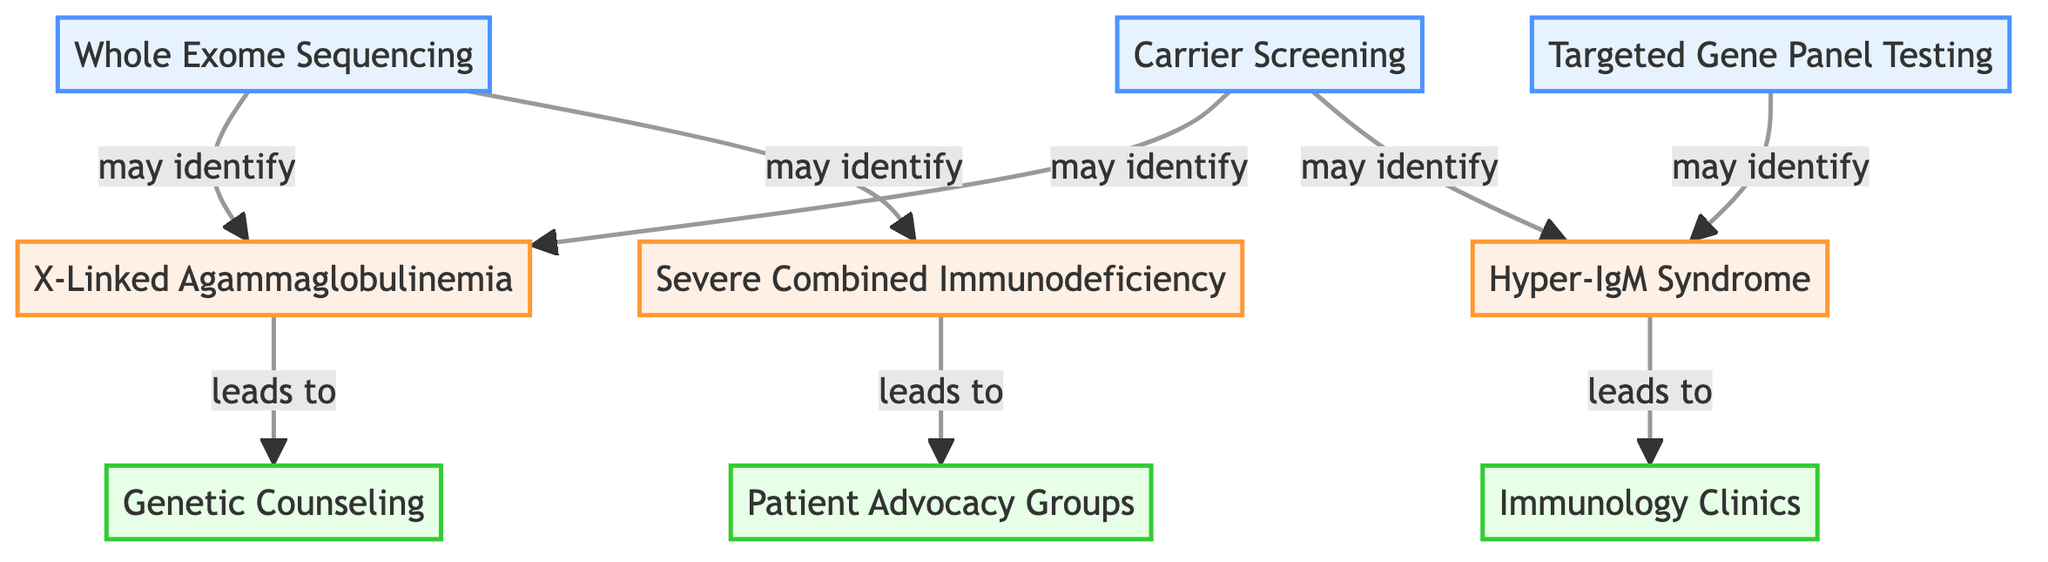What are the three genetic testing options displayed in the diagram? The nodes listed under "genetic_testing" include Whole Exome Sequencing, Targeted Gene Panel Testing, and Carrier Screening. These are identified directly from the diagram nodes.
Answer: Whole Exome Sequencing, Targeted Gene Panel Testing, Carrier Screening How many potential diagnoses are identified in the diagram? There are three nodes listed under "potential_diagnoses," which are X-Linked Agammaglobulinemia, Severe Combined Immunodeficiency, and Hyper-IgM Syndrome, thus counting gives 3.
Answer: 3 Which support service is associated with Severe Combined Immunodeficiency? From the relationship shown in the diagram, Severe Combined Immunodeficiency has an edge leading to Patient Advocacy Groups, indicating they are associated.
Answer: Patient Advocacy Groups Which genetic testing option may identify Hyper-IgM Syndrome? The diagram indicates that it can be identified through Targeted Gene Panel Testing, which leads to this diagnosis according to the directed edge.
Answer: Targeted Gene Panel Testing What is the connection between X-Linked Agammaglobulinemia and Genetic Counseling? The diagram shows a directed edge from X-Linked Agammaglobulinemia to Genetic Counseling, meaning that this diagnosis leads directly to this support service.
Answer: Genetic Counseling How many edges connect the genetic testing options to the potential diagnoses? Counting the directed edges, there are five edges originating from genetic testing options towards potential diagnoses, which can be found in the edges section of the diagram.
Answer: 5 Which diagnosis leads to Immunology Clinics according to the diagram? The edge from Hyper-IgM Syndrome leads to Immunology Clinics, which indicates that this potential diagnosis connects directly to that support service.
Answer: Hyper-IgM Syndrome What would be the effect of conducting Carrier Screening according to the diagram? The Carrier Screening option may identify two diagnoses: X-Linked Agammaglobulinemia and Hyper-IgM Syndrome, as shown by the two directed edges from this testing option.
Answer: X-Linked Agammaglobulinemia, Hyper-IgM Syndrome What types of support services are displayed in the graph? The nodes categorized under "support_services" include Genetic Counseling, Patient Advocacy Groups, and Immunology Clinics. This provides a complete list of the available support services.
Answer: Genetic Counseling, Patient Advocacy Groups, Immunology Clinics 